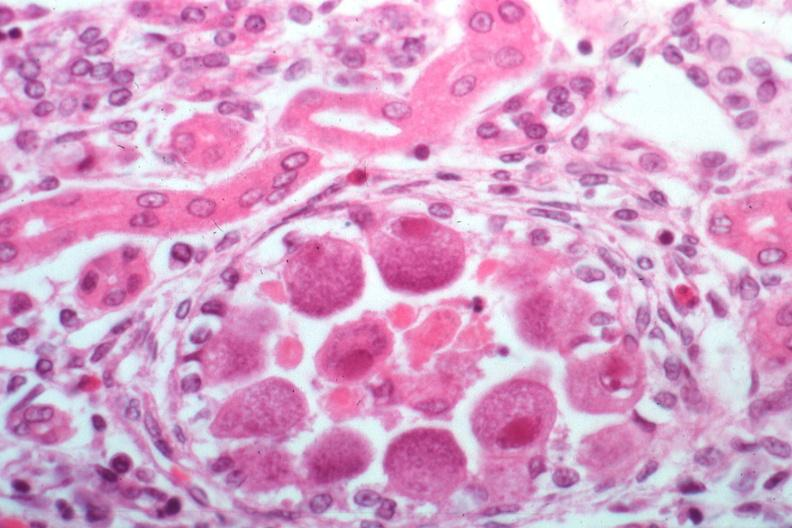where is this?
Answer the question using a single word or phrase. Urinary 